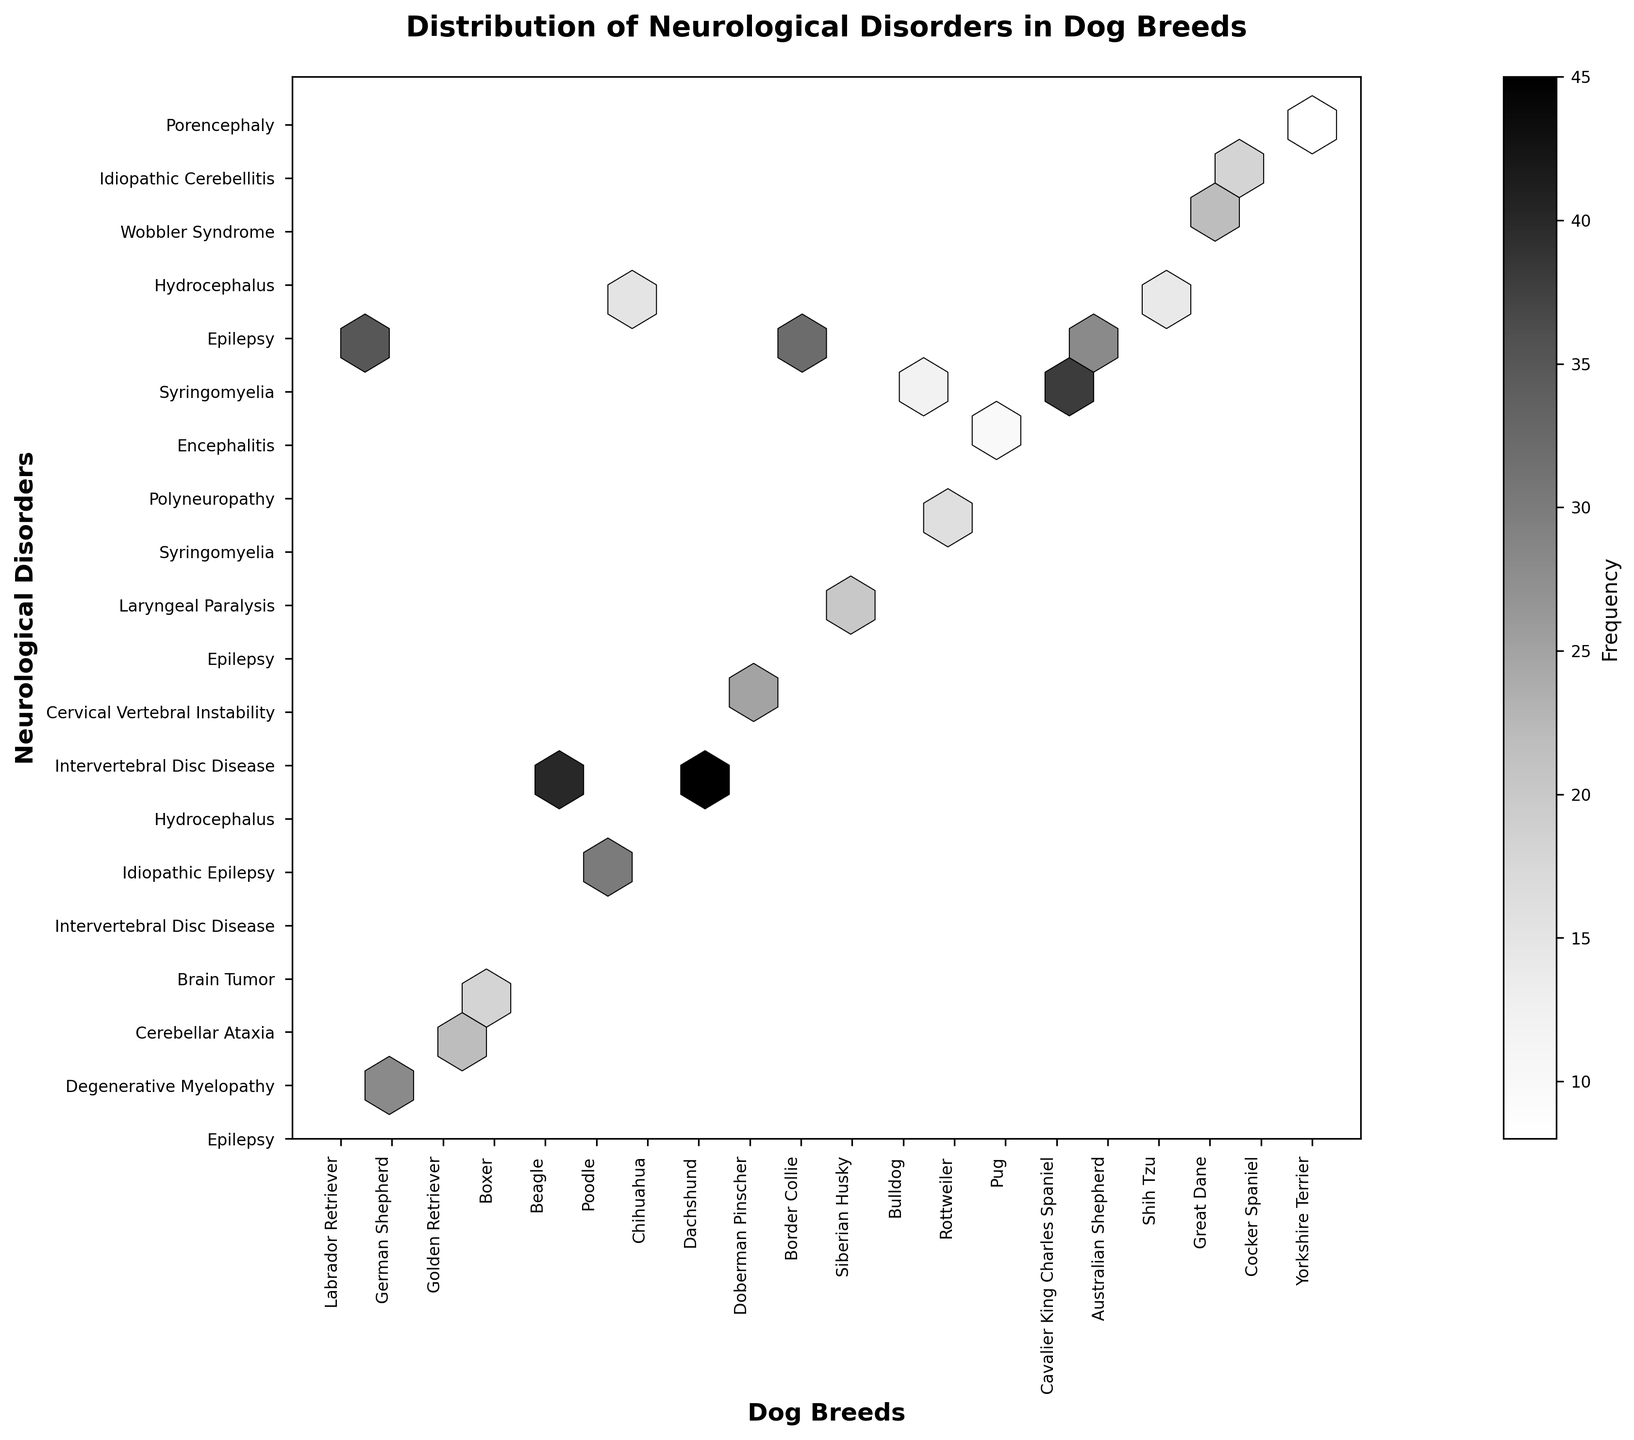what is the title of the plot? The title is shown at the top center of the plot in bold and larger font size. It summarizes the content of the plot.
Answer: Distribution of Neurological Disorders in Dog Breeds Which dog breed has the highest frequency of Intervertebral Disc Disease? By examining the hexbin plot, look for the breed associated with Intervertebral Disc Disease and identify the highest frequency in that category.
Answer: Dachshund What is the label of the x-axis? The label of the x-axis is given below the horizontal axis, explaining what the axis represents.
Answer: Dog Breeds Between Epilepsy and Idiopathic Epilepsy, which disorder is more commonly found among the listed dog breeds? Check the frequencies in the hexbins associated with both Epilepsy and Idiopathic Epilepsy to determine which has higher values.
Answer: Epilepsy How many dog breeds have frequencies greater than 30 for any disorder? Look for hexagons with color intensity indicating a frequency above 30 and count the number of unique dog breeds these hexagons represent.
Answer: 4 breeds Which disorder has a frequency of more than 20 in Golden Retriever and Border Collie? Examine the hexagons corresponding to Golden Retriever and Border Collie breeds for frequencies above 20, and identify the associated disorder.
Answer: Epilepsy What is the color representation for the most frequent disorder, and what frequency does this color correspond to? The color bar on the side of the hexbin plot indicates the frequency represented by each color. Identify the color for the highest value and its corresponding frequency.
Answer: Dark gray, 45 Which breeding has the lowest frequency disorder and what is the disorder? Check for the hexagon with the lowest color intensity and identify the breed and the corresponding disorder noted.
Answer: Yorkshire Terrier, Porencephaly What is the frequency of Syringomyelia in Cavalier King Charles Spaniel compared to Bulldog? Identify the hexagons associated with Syringomyelia for both Cavalier King Charles Spaniel and Bulldog, and compare their frequencies.
Answer: 38, 12 Which breed is associated with the disorder Wobbler Syndrome, and what is the frequency? Find the hexagon representing Wobbler Syndrome and identify the associated breed and its frequency value.
Answer: Great Dane, 22 